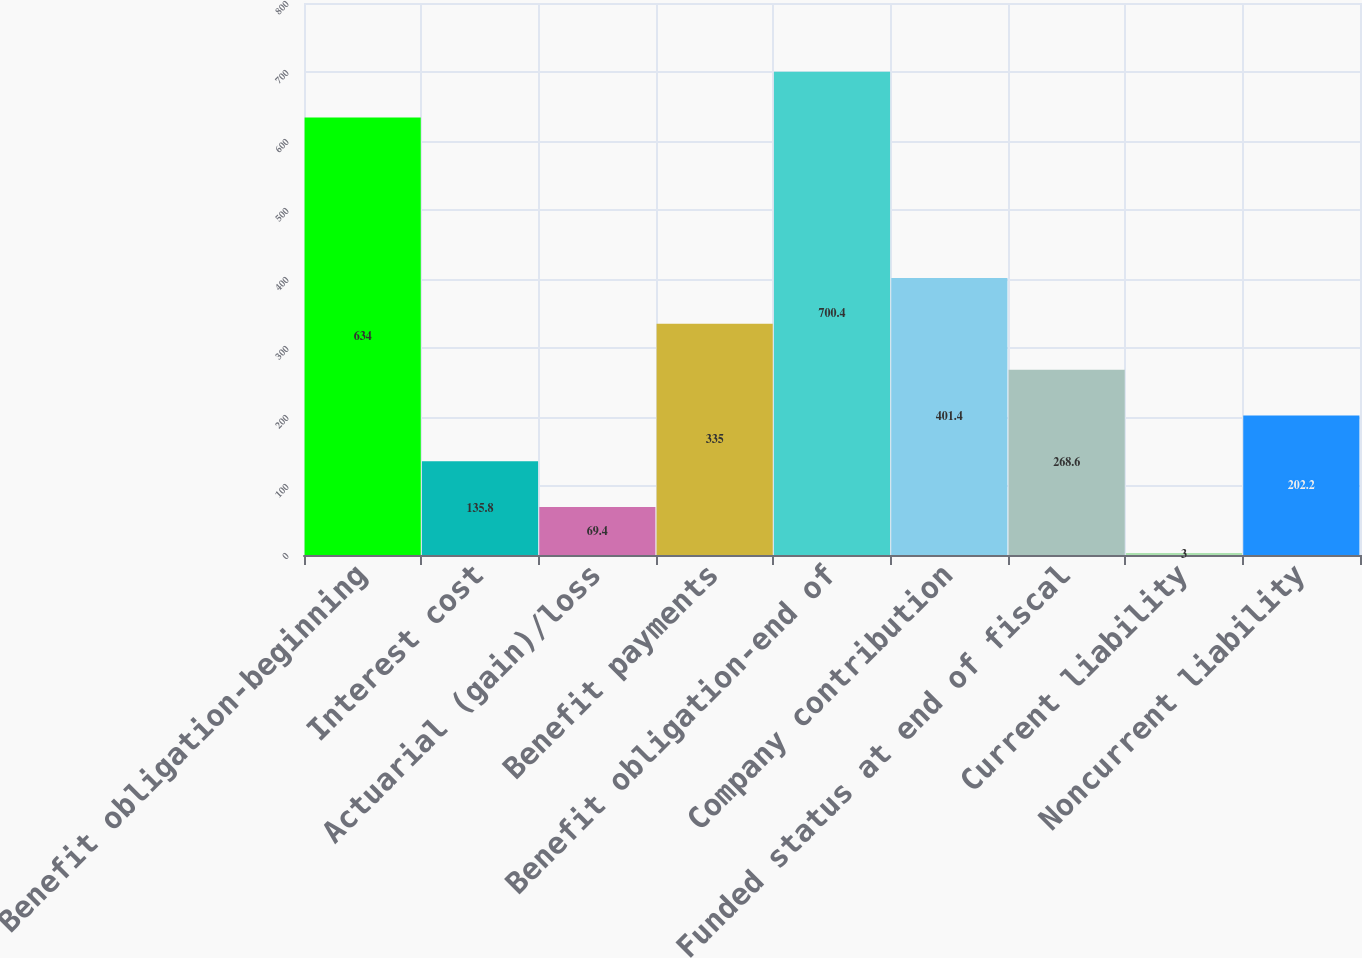Convert chart to OTSL. <chart><loc_0><loc_0><loc_500><loc_500><bar_chart><fcel>Benefit obligation-beginning<fcel>Interest cost<fcel>Actuarial (gain)/loss<fcel>Benefit payments<fcel>Benefit obligation-end of<fcel>Company contribution<fcel>Funded status at end of fiscal<fcel>Current liability<fcel>Noncurrent liability<nl><fcel>634<fcel>135.8<fcel>69.4<fcel>335<fcel>700.4<fcel>401.4<fcel>268.6<fcel>3<fcel>202.2<nl></chart> 